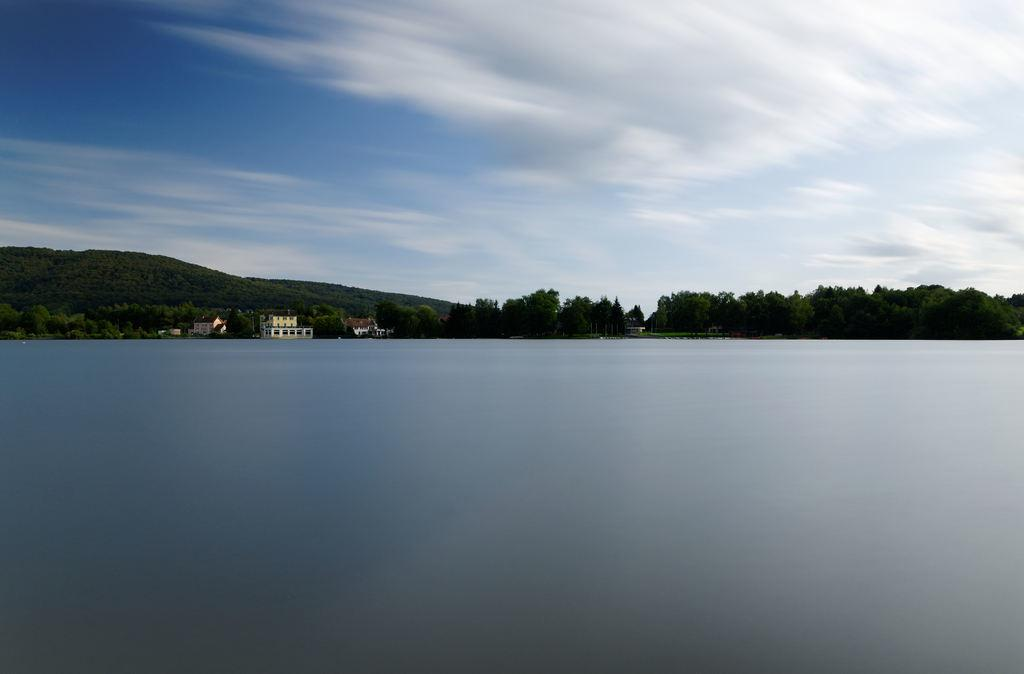What is visible in the image? Water is visible in the image. What can be seen in the background of the image? There are buildings, trees, a mountain, and the sky visible in the background of the image. What type of pollution can be seen in the image? There is no pollution visible in the image. Who is the writer in the image? There is no writer present in the image. 